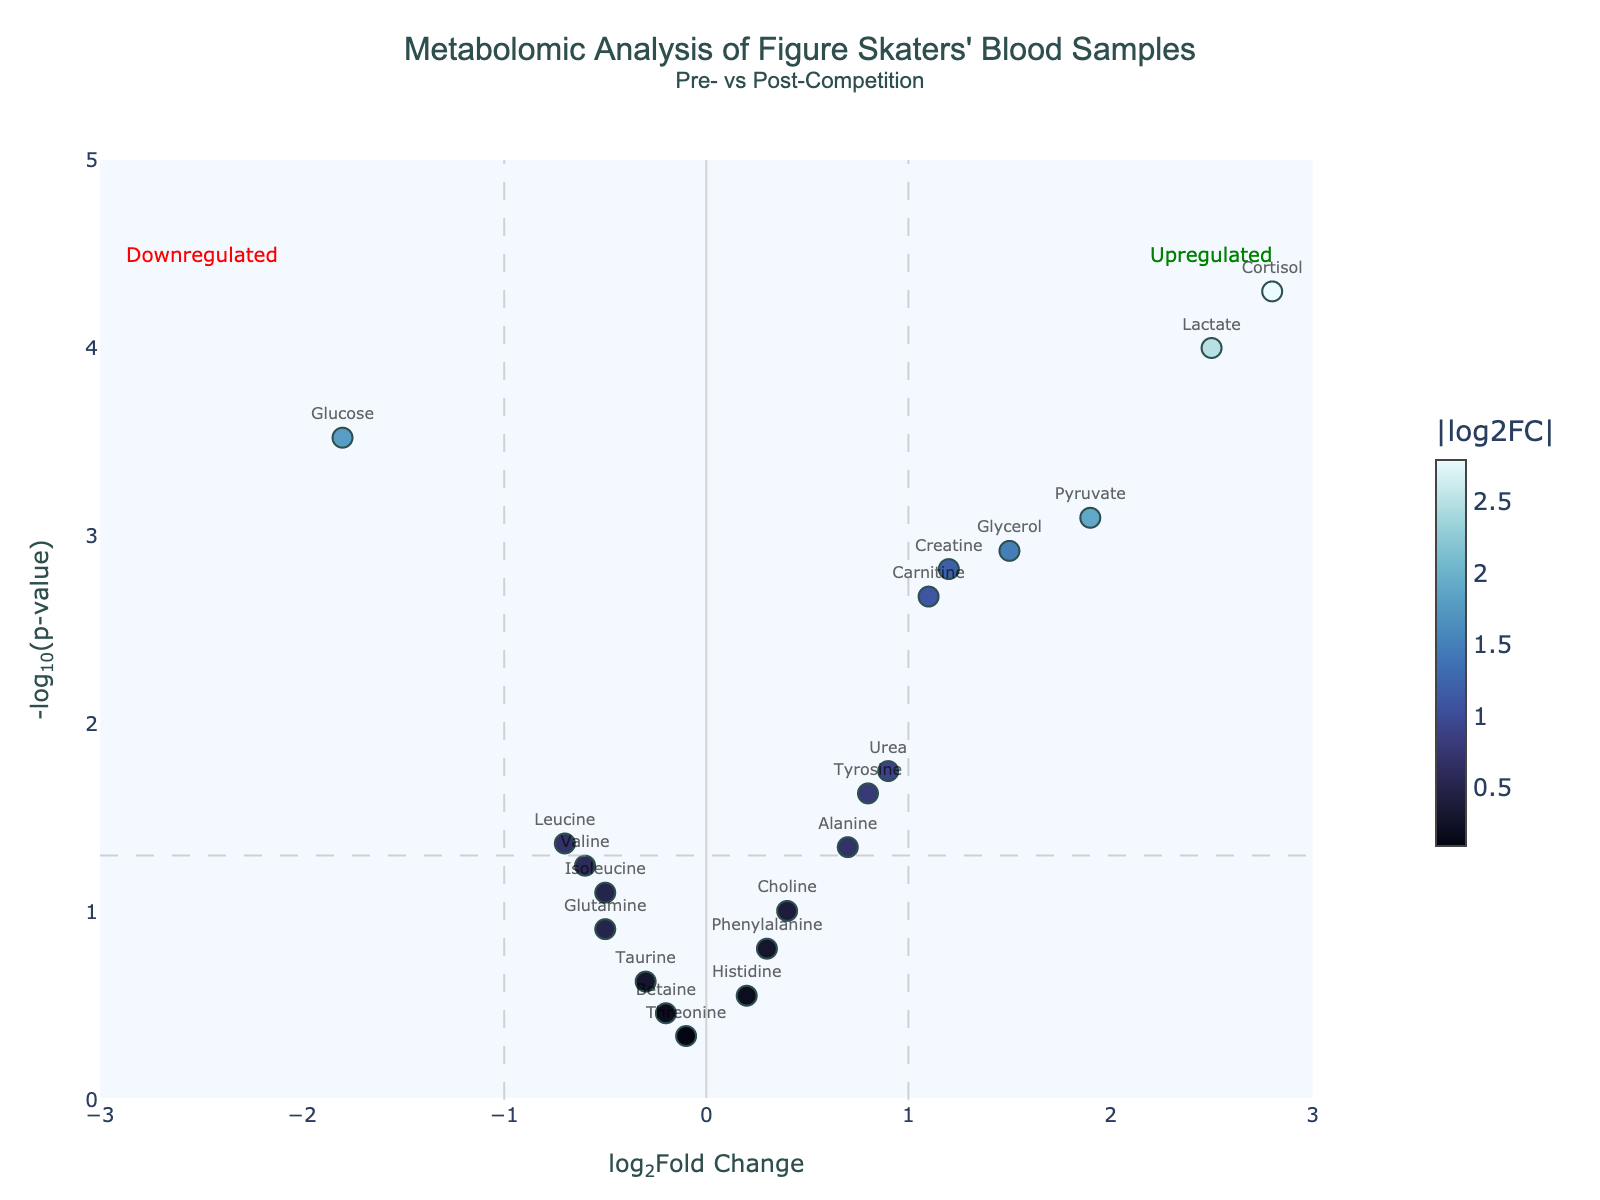Which metabolite has the highest -log10(p-value)? Look at the y-axis for the highest point and hover over it to find the metabolite.
Answer: Cortisol How many metabolites exceed the log2FoldChange threshold of 1? Count the data points with log2FoldChange greater than 1 or less than -1 by looking at the points to the left and right of the vertical lines at x=1 and x=-1.
Answer: 4 Which metabolites are downregulated with a significant p-value? Look for metabolites on the left side of the vertical line at x=-1 and above the horizontal line at y=-log10(0.05).
Answer: Glucose, Leucine What's the log2FoldChange value of Lactate? Hover over the point labeled Lactate to see its log2FoldChange value.
Answer: 2.5 Is Pyruvate upregulated or downregulated, and what is its log2FoldChange? Find the Pyruvate point and check its position relative to the vertical line at x=0.
Answer: Upregulated, 1.9 What is the p-value threshold used in the plot? Refer to the horizontal dashed line which represents the -log10 transformation of the p-value threshold.
Answer: 0.05 Which metabolite has the smallest p-value? Identify the highest point on the y-axis and hover over it to find the metabolite.
Answer: Cortisol Which metabolites appear to be not significantly different pre- vs post-competition? Identify points below the horizontal line at y=-log10(0.05).
Answer: Glutamine, Taurine, Betaine, Choline, Phenylalanine, Threonine, Histidine Compare the log2FoldChange of Carnitine and Creatine. Which is higher, and by how much? Check the locations and hover over Carnitine and Creatine points, then subtract their log2FoldChange values.
Answer: Carnitine is higher by 0.1 